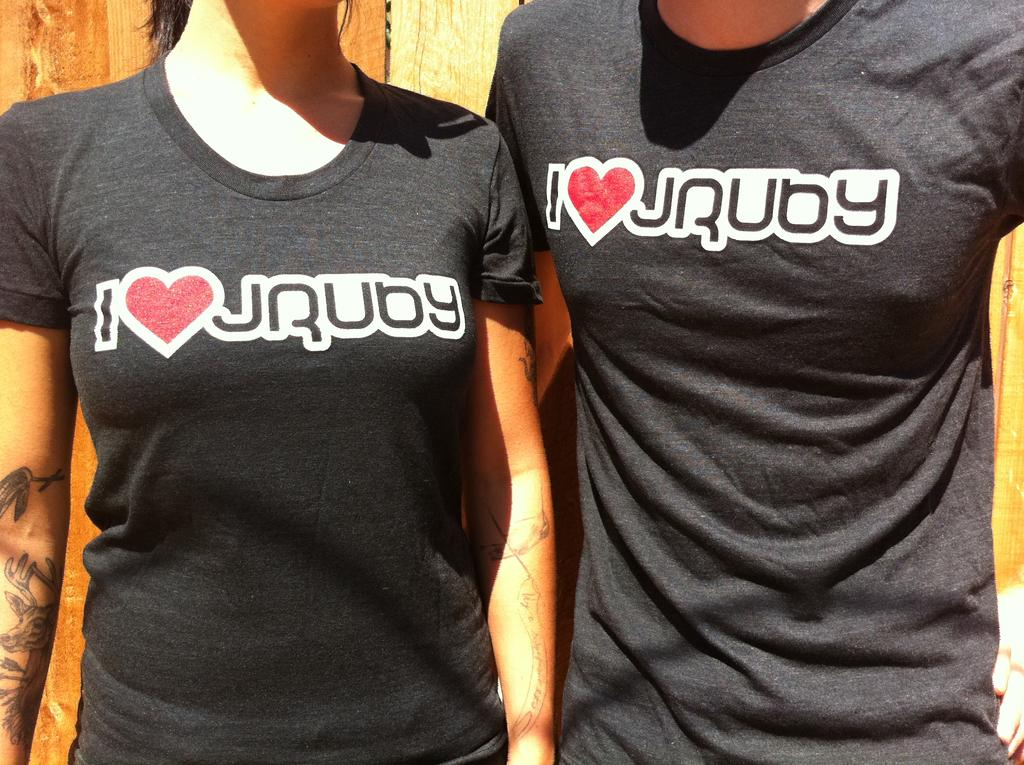<image>
Describe the image concisely. Two people in matching black shirts that say I love rubgy. 